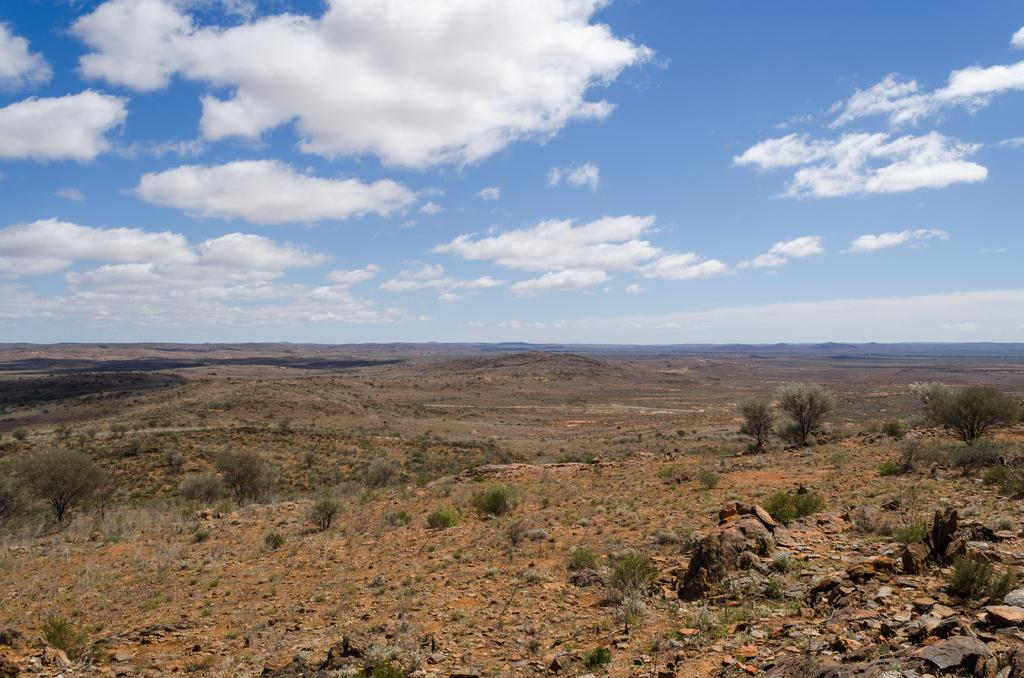What is at the bottom of the image? There is a ground at the bottom of the image, along with plants and rocks. Can you describe the plants in the image? The plants in the image are located at the bottom of the image. What is visible at the top of the image? The sky is visible at the top of the image. What is the condition of the sky in the image? The sky is cloudy in the image. What type of muscle can be seen flexing in the image? There is no muscle present in the image; it features a ground, plants, rocks, and a cloudy sky. Are there any cacti among the plants in the image? The provided facts do not mention any specific type of plants, so it cannot be determined if there are cacti or any other specific plant species in the image. 